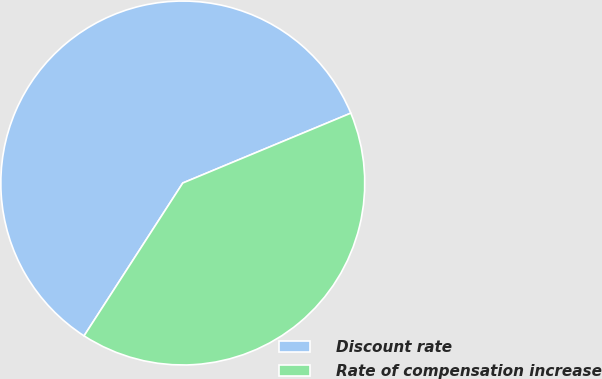<chart> <loc_0><loc_0><loc_500><loc_500><pie_chart><fcel>Discount rate<fcel>Rate of compensation increase<nl><fcel>59.6%<fcel>40.4%<nl></chart> 